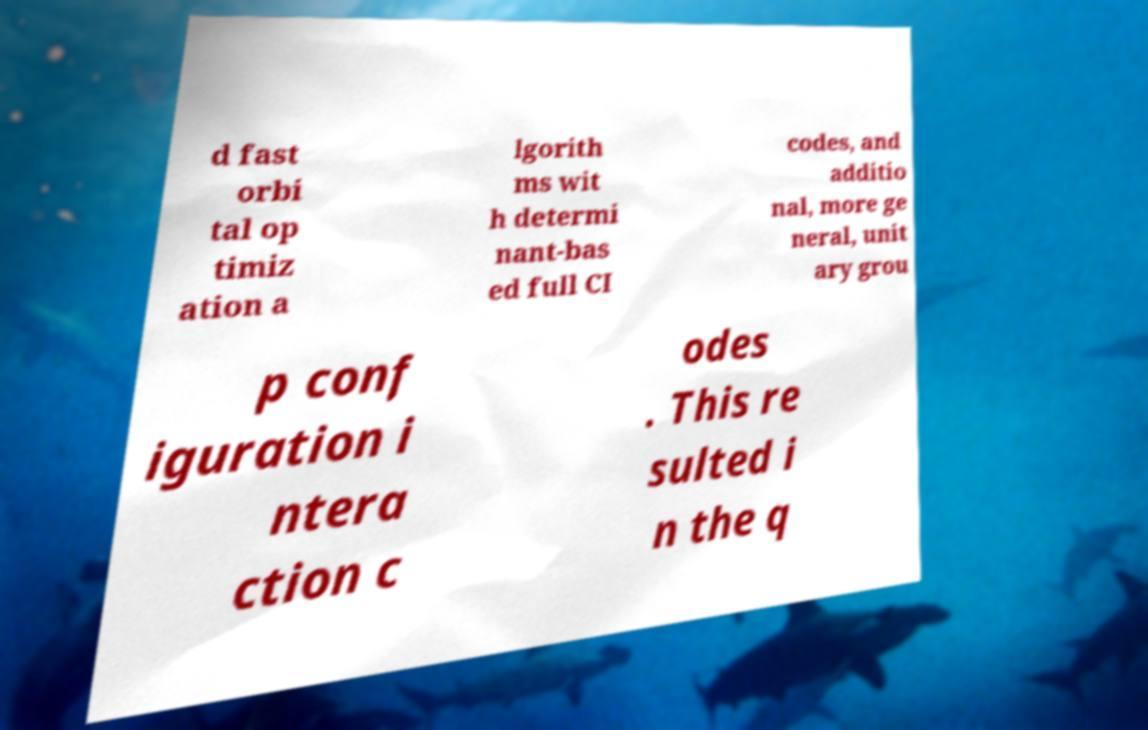Could you assist in decoding the text presented in this image and type it out clearly? d fast orbi tal op timiz ation a lgorith ms wit h determi nant-bas ed full CI codes, and additio nal, more ge neral, unit ary grou p conf iguration i ntera ction c odes . This re sulted i n the q 